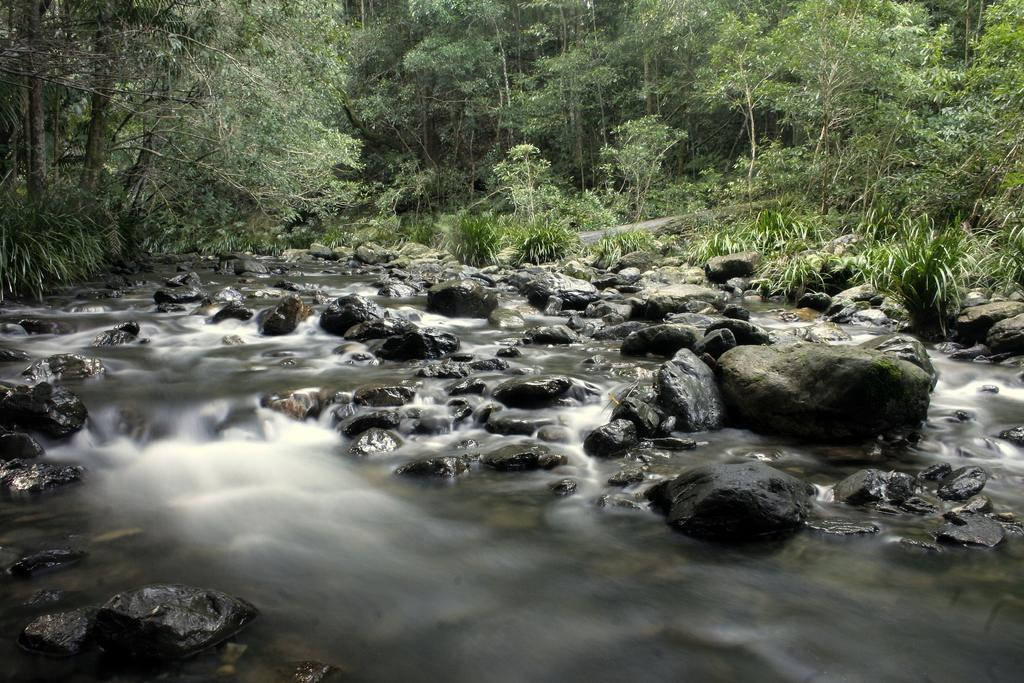What can be seen at the bottom of the image? There are many stones in the water at the bottom of the image. What is visible in the background of the image? There are trees in the background of the image. What type of vegetation is present on the ground in the image? There is grass on the ground in the image. What type of music can be heard playing in the background of the image? There is no music present in the image; it is a visual representation of a natural scene. Is there a meeting taking place in the image? There is no indication of a meeting in the image; it depicts a natural landscape with stones, water, trees, and grass. 